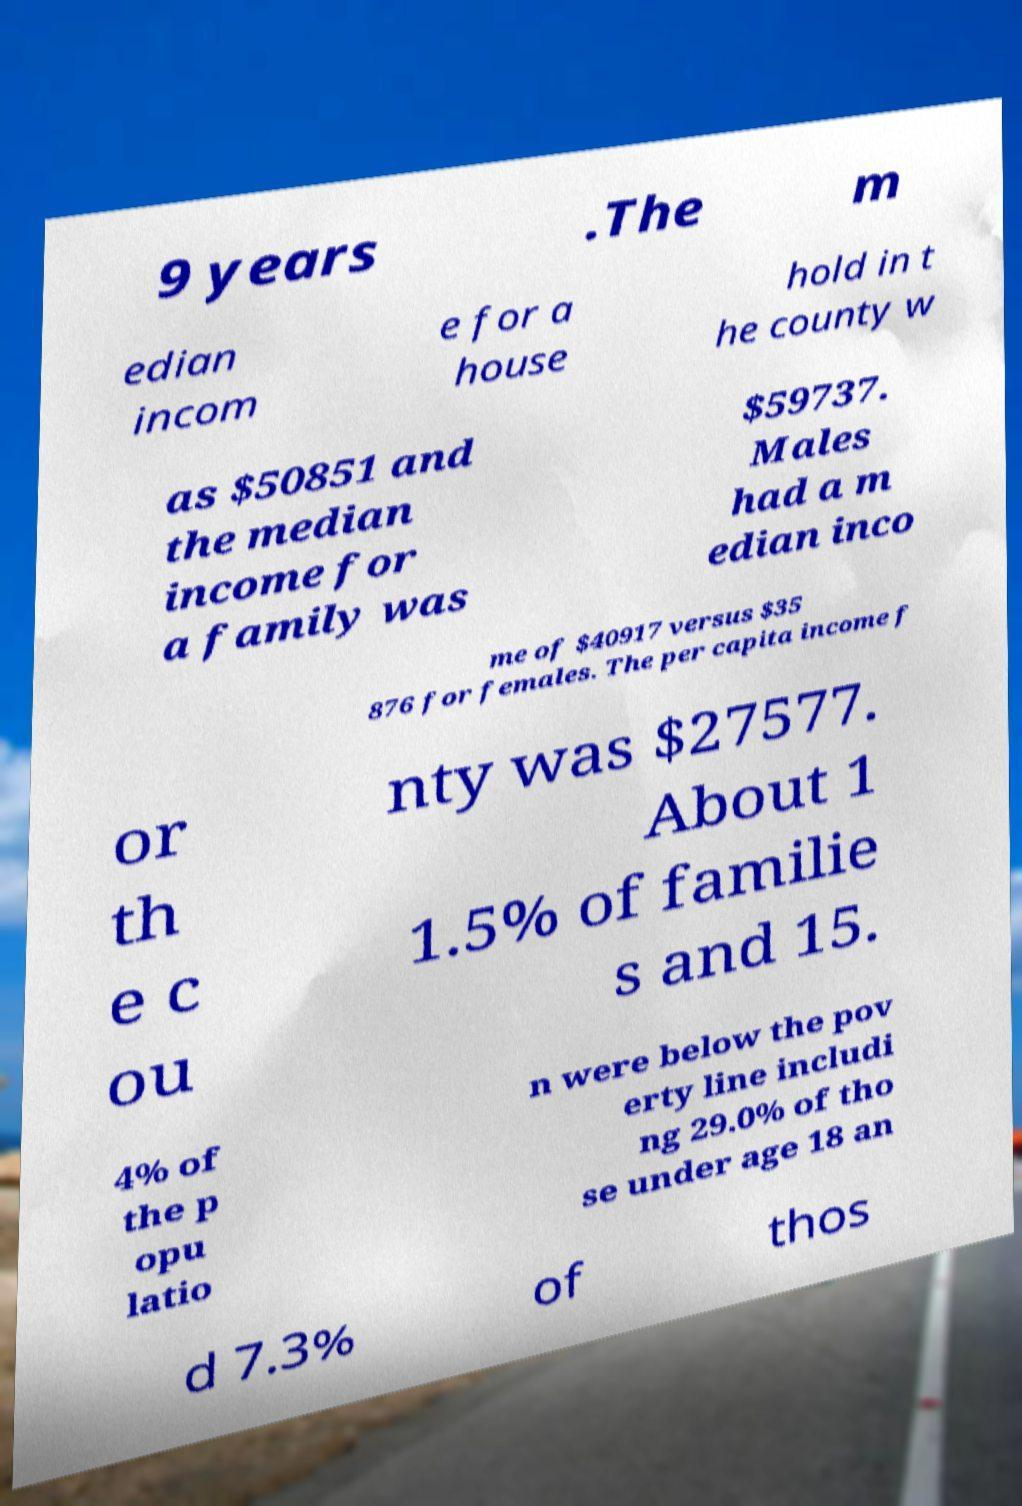Could you assist in decoding the text presented in this image and type it out clearly? 9 years .The m edian incom e for a house hold in t he county w as $50851 and the median income for a family was $59737. Males had a m edian inco me of $40917 versus $35 876 for females. The per capita income f or th e c ou nty was $27577. About 1 1.5% of familie s and 15. 4% of the p opu latio n were below the pov erty line includi ng 29.0% of tho se under age 18 an d 7.3% of thos 